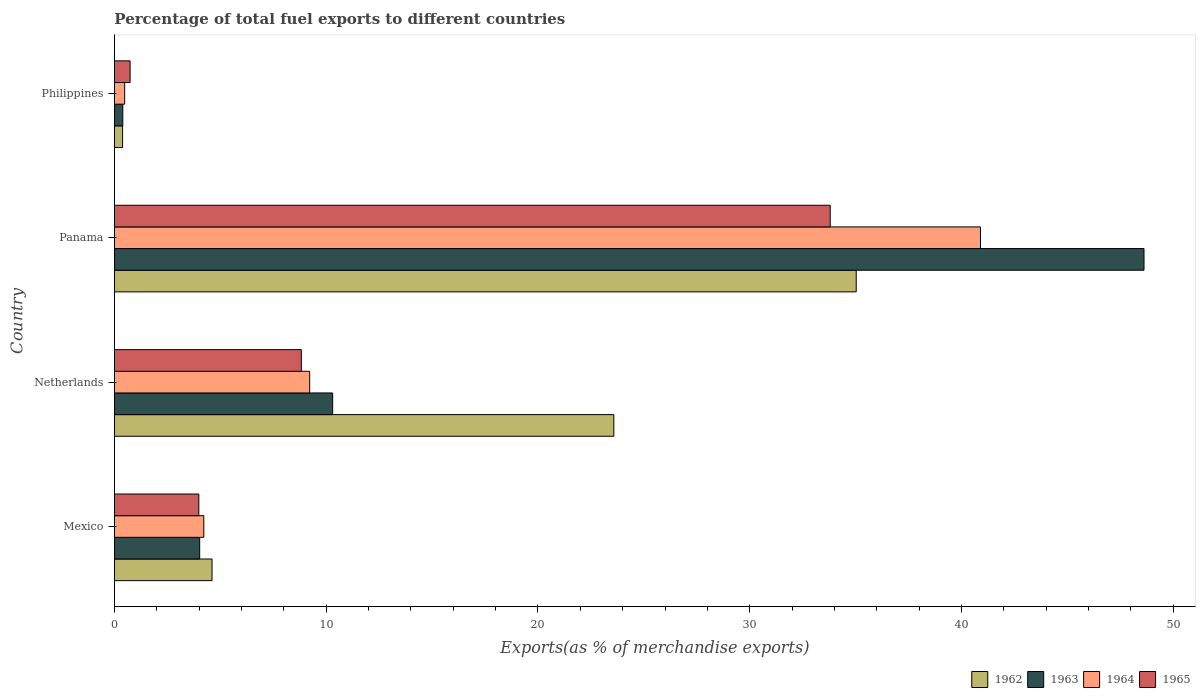How many different coloured bars are there?
Offer a terse response. 4. Are the number of bars on each tick of the Y-axis equal?
Keep it short and to the point. Yes. How many bars are there on the 1st tick from the top?
Your answer should be very brief. 4. How many bars are there on the 2nd tick from the bottom?
Provide a short and direct response. 4. In how many cases, is the number of bars for a given country not equal to the number of legend labels?
Your answer should be compact. 0. What is the percentage of exports to different countries in 1963 in Panama?
Ensure brevity in your answer.  48.62. Across all countries, what is the maximum percentage of exports to different countries in 1964?
Make the answer very short. 40.9. Across all countries, what is the minimum percentage of exports to different countries in 1962?
Provide a short and direct response. 0.38. In which country was the percentage of exports to different countries in 1963 maximum?
Provide a short and direct response. Panama. What is the total percentage of exports to different countries in 1965 in the graph?
Make the answer very short. 47.35. What is the difference between the percentage of exports to different countries in 1962 in Panama and that in Philippines?
Your answer should be very brief. 34.64. What is the difference between the percentage of exports to different countries in 1962 in Mexico and the percentage of exports to different countries in 1965 in Panama?
Give a very brief answer. -29.19. What is the average percentage of exports to different countries in 1963 per country?
Provide a succinct answer. 15.84. What is the difference between the percentage of exports to different countries in 1962 and percentage of exports to different countries in 1964 in Netherlands?
Offer a very short reply. 14.36. In how many countries, is the percentage of exports to different countries in 1962 greater than 14 %?
Give a very brief answer. 2. What is the ratio of the percentage of exports to different countries in 1963 in Mexico to that in Philippines?
Provide a short and direct response. 10.17. What is the difference between the highest and the second highest percentage of exports to different countries in 1963?
Your answer should be compact. 38.32. What is the difference between the highest and the lowest percentage of exports to different countries in 1965?
Offer a very short reply. 33.06. Is it the case that in every country, the sum of the percentage of exports to different countries in 1965 and percentage of exports to different countries in 1963 is greater than the sum of percentage of exports to different countries in 1962 and percentage of exports to different countries in 1964?
Your answer should be very brief. No. What does the 2nd bar from the top in Panama represents?
Ensure brevity in your answer.  1964. What does the 4th bar from the bottom in Netherlands represents?
Provide a short and direct response. 1965. Is it the case that in every country, the sum of the percentage of exports to different countries in 1964 and percentage of exports to different countries in 1962 is greater than the percentage of exports to different countries in 1963?
Keep it short and to the point. Yes. How many bars are there?
Ensure brevity in your answer.  16. How many countries are there in the graph?
Offer a terse response. 4. Does the graph contain any zero values?
Your response must be concise. No. Does the graph contain grids?
Offer a terse response. No. Where does the legend appear in the graph?
Ensure brevity in your answer.  Bottom right. How many legend labels are there?
Ensure brevity in your answer.  4. What is the title of the graph?
Provide a succinct answer. Percentage of total fuel exports to different countries. Does "1979" appear as one of the legend labels in the graph?
Your response must be concise. No. What is the label or title of the X-axis?
Your response must be concise. Exports(as % of merchandise exports). What is the label or title of the Y-axis?
Make the answer very short. Country. What is the Exports(as % of merchandise exports) of 1962 in Mexico?
Provide a short and direct response. 4.61. What is the Exports(as % of merchandise exports) in 1963 in Mexico?
Provide a succinct answer. 4.03. What is the Exports(as % of merchandise exports) of 1964 in Mexico?
Provide a succinct answer. 4.22. What is the Exports(as % of merchandise exports) in 1965 in Mexico?
Your answer should be very brief. 3.99. What is the Exports(as % of merchandise exports) of 1962 in Netherlands?
Offer a very short reply. 23.58. What is the Exports(as % of merchandise exports) of 1963 in Netherlands?
Offer a terse response. 10.31. What is the Exports(as % of merchandise exports) in 1964 in Netherlands?
Your response must be concise. 9.22. What is the Exports(as % of merchandise exports) of 1965 in Netherlands?
Give a very brief answer. 8.83. What is the Exports(as % of merchandise exports) in 1962 in Panama?
Your response must be concise. 35.03. What is the Exports(as % of merchandise exports) in 1963 in Panama?
Ensure brevity in your answer.  48.62. What is the Exports(as % of merchandise exports) in 1964 in Panama?
Keep it short and to the point. 40.9. What is the Exports(as % of merchandise exports) in 1965 in Panama?
Keep it short and to the point. 33.8. What is the Exports(as % of merchandise exports) in 1962 in Philippines?
Make the answer very short. 0.38. What is the Exports(as % of merchandise exports) in 1963 in Philippines?
Your answer should be very brief. 0.4. What is the Exports(as % of merchandise exports) in 1964 in Philippines?
Make the answer very short. 0.48. What is the Exports(as % of merchandise exports) in 1965 in Philippines?
Give a very brief answer. 0.74. Across all countries, what is the maximum Exports(as % of merchandise exports) of 1962?
Your response must be concise. 35.03. Across all countries, what is the maximum Exports(as % of merchandise exports) of 1963?
Your answer should be very brief. 48.62. Across all countries, what is the maximum Exports(as % of merchandise exports) of 1964?
Your response must be concise. 40.9. Across all countries, what is the maximum Exports(as % of merchandise exports) in 1965?
Keep it short and to the point. 33.8. Across all countries, what is the minimum Exports(as % of merchandise exports) in 1962?
Provide a succinct answer. 0.38. Across all countries, what is the minimum Exports(as % of merchandise exports) in 1963?
Your answer should be very brief. 0.4. Across all countries, what is the minimum Exports(as % of merchandise exports) in 1964?
Your answer should be very brief. 0.48. Across all countries, what is the minimum Exports(as % of merchandise exports) in 1965?
Ensure brevity in your answer.  0.74. What is the total Exports(as % of merchandise exports) of 1962 in the graph?
Your response must be concise. 63.61. What is the total Exports(as % of merchandise exports) in 1963 in the graph?
Your answer should be compact. 63.35. What is the total Exports(as % of merchandise exports) in 1964 in the graph?
Your answer should be very brief. 54.82. What is the total Exports(as % of merchandise exports) of 1965 in the graph?
Make the answer very short. 47.35. What is the difference between the Exports(as % of merchandise exports) in 1962 in Mexico and that in Netherlands?
Ensure brevity in your answer.  -18.97. What is the difference between the Exports(as % of merchandise exports) of 1963 in Mexico and that in Netherlands?
Provide a short and direct response. -6.28. What is the difference between the Exports(as % of merchandise exports) of 1964 in Mexico and that in Netherlands?
Offer a terse response. -5. What is the difference between the Exports(as % of merchandise exports) of 1965 in Mexico and that in Netherlands?
Make the answer very short. -4.84. What is the difference between the Exports(as % of merchandise exports) of 1962 in Mexico and that in Panama?
Offer a very short reply. -30.42. What is the difference between the Exports(as % of merchandise exports) of 1963 in Mexico and that in Panama?
Give a very brief answer. -44.59. What is the difference between the Exports(as % of merchandise exports) in 1964 in Mexico and that in Panama?
Your response must be concise. -36.68. What is the difference between the Exports(as % of merchandise exports) in 1965 in Mexico and that in Panama?
Make the answer very short. -29.82. What is the difference between the Exports(as % of merchandise exports) in 1962 in Mexico and that in Philippines?
Your answer should be compact. 4.22. What is the difference between the Exports(as % of merchandise exports) of 1963 in Mexico and that in Philippines?
Provide a short and direct response. 3.63. What is the difference between the Exports(as % of merchandise exports) in 1964 in Mexico and that in Philippines?
Give a very brief answer. 3.74. What is the difference between the Exports(as % of merchandise exports) in 1965 in Mexico and that in Philippines?
Keep it short and to the point. 3.25. What is the difference between the Exports(as % of merchandise exports) in 1962 in Netherlands and that in Panama?
Make the answer very short. -11.45. What is the difference between the Exports(as % of merchandise exports) in 1963 in Netherlands and that in Panama?
Make the answer very short. -38.32. What is the difference between the Exports(as % of merchandise exports) of 1964 in Netherlands and that in Panama?
Keep it short and to the point. -31.68. What is the difference between the Exports(as % of merchandise exports) in 1965 in Netherlands and that in Panama?
Make the answer very short. -24.98. What is the difference between the Exports(as % of merchandise exports) in 1962 in Netherlands and that in Philippines?
Offer a very short reply. 23.2. What is the difference between the Exports(as % of merchandise exports) in 1963 in Netherlands and that in Philippines?
Your response must be concise. 9.91. What is the difference between the Exports(as % of merchandise exports) in 1964 in Netherlands and that in Philippines?
Make the answer very short. 8.74. What is the difference between the Exports(as % of merchandise exports) in 1965 in Netherlands and that in Philippines?
Give a very brief answer. 8.09. What is the difference between the Exports(as % of merchandise exports) of 1962 in Panama and that in Philippines?
Offer a very short reply. 34.65. What is the difference between the Exports(as % of merchandise exports) in 1963 in Panama and that in Philippines?
Provide a short and direct response. 48.22. What is the difference between the Exports(as % of merchandise exports) of 1964 in Panama and that in Philippines?
Make the answer very short. 40.41. What is the difference between the Exports(as % of merchandise exports) in 1965 in Panama and that in Philippines?
Keep it short and to the point. 33.06. What is the difference between the Exports(as % of merchandise exports) in 1962 in Mexico and the Exports(as % of merchandise exports) in 1963 in Netherlands?
Provide a short and direct response. -5.7. What is the difference between the Exports(as % of merchandise exports) of 1962 in Mexico and the Exports(as % of merchandise exports) of 1964 in Netherlands?
Keep it short and to the point. -4.61. What is the difference between the Exports(as % of merchandise exports) of 1962 in Mexico and the Exports(as % of merchandise exports) of 1965 in Netherlands?
Your answer should be very brief. -4.22. What is the difference between the Exports(as % of merchandise exports) of 1963 in Mexico and the Exports(as % of merchandise exports) of 1964 in Netherlands?
Your response must be concise. -5.19. What is the difference between the Exports(as % of merchandise exports) of 1963 in Mexico and the Exports(as % of merchandise exports) of 1965 in Netherlands?
Keep it short and to the point. -4.8. What is the difference between the Exports(as % of merchandise exports) in 1964 in Mexico and the Exports(as % of merchandise exports) in 1965 in Netherlands?
Offer a very short reply. -4.61. What is the difference between the Exports(as % of merchandise exports) of 1962 in Mexico and the Exports(as % of merchandise exports) of 1963 in Panama?
Provide a succinct answer. -44.01. What is the difference between the Exports(as % of merchandise exports) in 1962 in Mexico and the Exports(as % of merchandise exports) in 1964 in Panama?
Keep it short and to the point. -36.29. What is the difference between the Exports(as % of merchandise exports) in 1962 in Mexico and the Exports(as % of merchandise exports) in 1965 in Panama?
Your answer should be very brief. -29.19. What is the difference between the Exports(as % of merchandise exports) of 1963 in Mexico and the Exports(as % of merchandise exports) of 1964 in Panama?
Offer a very short reply. -36.87. What is the difference between the Exports(as % of merchandise exports) of 1963 in Mexico and the Exports(as % of merchandise exports) of 1965 in Panama?
Ensure brevity in your answer.  -29.78. What is the difference between the Exports(as % of merchandise exports) in 1964 in Mexico and the Exports(as % of merchandise exports) in 1965 in Panama?
Make the answer very short. -29.58. What is the difference between the Exports(as % of merchandise exports) in 1962 in Mexico and the Exports(as % of merchandise exports) in 1963 in Philippines?
Provide a succinct answer. 4.21. What is the difference between the Exports(as % of merchandise exports) of 1962 in Mexico and the Exports(as % of merchandise exports) of 1964 in Philippines?
Your answer should be very brief. 4.13. What is the difference between the Exports(as % of merchandise exports) in 1962 in Mexico and the Exports(as % of merchandise exports) in 1965 in Philippines?
Make the answer very short. 3.87. What is the difference between the Exports(as % of merchandise exports) in 1963 in Mexico and the Exports(as % of merchandise exports) in 1964 in Philippines?
Give a very brief answer. 3.54. What is the difference between the Exports(as % of merchandise exports) in 1963 in Mexico and the Exports(as % of merchandise exports) in 1965 in Philippines?
Your answer should be very brief. 3.29. What is the difference between the Exports(as % of merchandise exports) of 1964 in Mexico and the Exports(as % of merchandise exports) of 1965 in Philippines?
Make the answer very short. 3.48. What is the difference between the Exports(as % of merchandise exports) of 1962 in Netherlands and the Exports(as % of merchandise exports) of 1963 in Panama?
Your answer should be very brief. -25.04. What is the difference between the Exports(as % of merchandise exports) in 1962 in Netherlands and the Exports(as % of merchandise exports) in 1964 in Panama?
Offer a very short reply. -17.31. What is the difference between the Exports(as % of merchandise exports) in 1962 in Netherlands and the Exports(as % of merchandise exports) in 1965 in Panama?
Ensure brevity in your answer.  -10.22. What is the difference between the Exports(as % of merchandise exports) in 1963 in Netherlands and the Exports(as % of merchandise exports) in 1964 in Panama?
Your response must be concise. -30.59. What is the difference between the Exports(as % of merchandise exports) of 1963 in Netherlands and the Exports(as % of merchandise exports) of 1965 in Panama?
Give a very brief answer. -23.5. What is the difference between the Exports(as % of merchandise exports) of 1964 in Netherlands and the Exports(as % of merchandise exports) of 1965 in Panama?
Make the answer very short. -24.58. What is the difference between the Exports(as % of merchandise exports) of 1962 in Netherlands and the Exports(as % of merchandise exports) of 1963 in Philippines?
Provide a succinct answer. 23.19. What is the difference between the Exports(as % of merchandise exports) in 1962 in Netherlands and the Exports(as % of merchandise exports) in 1964 in Philippines?
Offer a terse response. 23.1. What is the difference between the Exports(as % of merchandise exports) in 1962 in Netherlands and the Exports(as % of merchandise exports) in 1965 in Philippines?
Your answer should be compact. 22.84. What is the difference between the Exports(as % of merchandise exports) of 1963 in Netherlands and the Exports(as % of merchandise exports) of 1964 in Philippines?
Keep it short and to the point. 9.82. What is the difference between the Exports(as % of merchandise exports) in 1963 in Netherlands and the Exports(as % of merchandise exports) in 1965 in Philippines?
Ensure brevity in your answer.  9.57. What is the difference between the Exports(as % of merchandise exports) of 1964 in Netherlands and the Exports(as % of merchandise exports) of 1965 in Philippines?
Your answer should be compact. 8.48. What is the difference between the Exports(as % of merchandise exports) in 1962 in Panama and the Exports(as % of merchandise exports) in 1963 in Philippines?
Provide a succinct answer. 34.63. What is the difference between the Exports(as % of merchandise exports) of 1962 in Panama and the Exports(as % of merchandise exports) of 1964 in Philippines?
Give a very brief answer. 34.55. What is the difference between the Exports(as % of merchandise exports) of 1962 in Panama and the Exports(as % of merchandise exports) of 1965 in Philippines?
Give a very brief answer. 34.29. What is the difference between the Exports(as % of merchandise exports) of 1963 in Panama and the Exports(as % of merchandise exports) of 1964 in Philippines?
Your answer should be compact. 48.14. What is the difference between the Exports(as % of merchandise exports) of 1963 in Panama and the Exports(as % of merchandise exports) of 1965 in Philippines?
Keep it short and to the point. 47.88. What is the difference between the Exports(as % of merchandise exports) of 1964 in Panama and the Exports(as % of merchandise exports) of 1965 in Philippines?
Your response must be concise. 40.16. What is the average Exports(as % of merchandise exports) of 1962 per country?
Ensure brevity in your answer.  15.9. What is the average Exports(as % of merchandise exports) in 1963 per country?
Make the answer very short. 15.84. What is the average Exports(as % of merchandise exports) in 1964 per country?
Your response must be concise. 13.71. What is the average Exports(as % of merchandise exports) of 1965 per country?
Make the answer very short. 11.84. What is the difference between the Exports(as % of merchandise exports) of 1962 and Exports(as % of merchandise exports) of 1963 in Mexico?
Ensure brevity in your answer.  0.58. What is the difference between the Exports(as % of merchandise exports) of 1962 and Exports(as % of merchandise exports) of 1964 in Mexico?
Your response must be concise. 0.39. What is the difference between the Exports(as % of merchandise exports) of 1962 and Exports(as % of merchandise exports) of 1965 in Mexico?
Make the answer very short. 0.62. What is the difference between the Exports(as % of merchandise exports) of 1963 and Exports(as % of merchandise exports) of 1964 in Mexico?
Your answer should be compact. -0.19. What is the difference between the Exports(as % of merchandise exports) of 1963 and Exports(as % of merchandise exports) of 1965 in Mexico?
Offer a terse response. 0.04. What is the difference between the Exports(as % of merchandise exports) of 1964 and Exports(as % of merchandise exports) of 1965 in Mexico?
Keep it short and to the point. 0.23. What is the difference between the Exports(as % of merchandise exports) in 1962 and Exports(as % of merchandise exports) in 1963 in Netherlands?
Make the answer very short. 13.28. What is the difference between the Exports(as % of merchandise exports) of 1962 and Exports(as % of merchandise exports) of 1964 in Netherlands?
Make the answer very short. 14.36. What is the difference between the Exports(as % of merchandise exports) in 1962 and Exports(as % of merchandise exports) in 1965 in Netherlands?
Provide a succinct answer. 14.76. What is the difference between the Exports(as % of merchandise exports) of 1963 and Exports(as % of merchandise exports) of 1964 in Netherlands?
Give a very brief answer. 1.09. What is the difference between the Exports(as % of merchandise exports) in 1963 and Exports(as % of merchandise exports) in 1965 in Netherlands?
Your response must be concise. 1.48. What is the difference between the Exports(as % of merchandise exports) in 1964 and Exports(as % of merchandise exports) in 1965 in Netherlands?
Give a very brief answer. 0.39. What is the difference between the Exports(as % of merchandise exports) in 1962 and Exports(as % of merchandise exports) in 1963 in Panama?
Give a very brief answer. -13.59. What is the difference between the Exports(as % of merchandise exports) of 1962 and Exports(as % of merchandise exports) of 1964 in Panama?
Offer a terse response. -5.87. What is the difference between the Exports(as % of merchandise exports) in 1962 and Exports(as % of merchandise exports) in 1965 in Panama?
Your answer should be compact. 1.23. What is the difference between the Exports(as % of merchandise exports) in 1963 and Exports(as % of merchandise exports) in 1964 in Panama?
Your response must be concise. 7.72. What is the difference between the Exports(as % of merchandise exports) of 1963 and Exports(as % of merchandise exports) of 1965 in Panama?
Offer a very short reply. 14.82. What is the difference between the Exports(as % of merchandise exports) of 1964 and Exports(as % of merchandise exports) of 1965 in Panama?
Offer a terse response. 7.1. What is the difference between the Exports(as % of merchandise exports) in 1962 and Exports(as % of merchandise exports) in 1963 in Philippines?
Provide a short and direct response. -0.01. What is the difference between the Exports(as % of merchandise exports) of 1962 and Exports(as % of merchandise exports) of 1964 in Philippines?
Your answer should be compact. -0.1. What is the difference between the Exports(as % of merchandise exports) of 1962 and Exports(as % of merchandise exports) of 1965 in Philippines?
Provide a short and direct response. -0.35. What is the difference between the Exports(as % of merchandise exports) in 1963 and Exports(as % of merchandise exports) in 1964 in Philippines?
Give a very brief answer. -0.09. What is the difference between the Exports(as % of merchandise exports) in 1963 and Exports(as % of merchandise exports) in 1965 in Philippines?
Provide a short and direct response. -0.34. What is the difference between the Exports(as % of merchandise exports) in 1964 and Exports(as % of merchandise exports) in 1965 in Philippines?
Provide a succinct answer. -0.26. What is the ratio of the Exports(as % of merchandise exports) of 1962 in Mexico to that in Netherlands?
Ensure brevity in your answer.  0.2. What is the ratio of the Exports(as % of merchandise exports) in 1963 in Mexico to that in Netherlands?
Give a very brief answer. 0.39. What is the ratio of the Exports(as % of merchandise exports) of 1964 in Mexico to that in Netherlands?
Keep it short and to the point. 0.46. What is the ratio of the Exports(as % of merchandise exports) of 1965 in Mexico to that in Netherlands?
Provide a succinct answer. 0.45. What is the ratio of the Exports(as % of merchandise exports) in 1962 in Mexico to that in Panama?
Keep it short and to the point. 0.13. What is the ratio of the Exports(as % of merchandise exports) of 1963 in Mexico to that in Panama?
Provide a succinct answer. 0.08. What is the ratio of the Exports(as % of merchandise exports) of 1964 in Mexico to that in Panama?
Offer a very short reply. 0.1. What is the ratio of the Exports(as % of merchandise exports) in 1965 in Mexico to that in Panama?
Provide a succinct answer. 0.12. What is the ratio of the Exports(as % of merchandise exports) in 1962 in Mexico to that in Philippines?
Your response must be concise. 11.97. What is the ratio of the Exports(as % of merchandise exports) in 1963 in Mexico to that in Philippines?
Your answer should be compact. 10.17. What is the ratio of the Exports(as % of merchandise exports) of 1964 in Mexico to that in Philippines?
Your answer should be very brief. 8.73. What is the ratio of the Exports(as % of merchandise exports) in 1965 in Mexico to that in Philippines?
Your answer should be compact. 5.39. What is the ratio of the Exports(as % of merchandise exports) of 1962 in Netherlands to that in Panama?
Ensure brevity in your answer.  0.67. What is the ratio of the Exports(as % of merchandise exports) of 1963 in Netherlands to that in Panama?
Your response must be concise. 0.21. What is the ratio of the Exports(as % of merchandise exports) in 1964 in Netherlands to that in Panama?
Your response must be concise. 0.23. What is the ratio of the Exports(as % of merchandise exports) in 1965 in Netherlands to that in Panama?
Provide a succinct answer. 0.26. What is the ratio of the Exports(as % of merchandise exports) of 1962 in Netherlands to that in Philippines?
Your response must be concise. 61.27. What is the ratio of the Exports(as % of merchandise exports) of 1963 in Netherlands to that in Philippines?
Ensure brevity in your answer.  26.03. What is the ratio of the Exports(as % of merchandise exports) of 1964 in Netherlands to that in Philippines?
Your answer should be compact. 19.07. What is the ratio of the Exports(as % of merchandise exports) of 1965 in Netherlands to that in Philippines?
Keep it short and to the point. 11.93. What is the ratio of the Exports(as % of merchandise exports) of 1962 in Panama to that in Philippines?
Offer a terse response. 91.01. What is the ratio of the Exports(as % of merchandise exports) of 1963 in Panama to that in Philippines?
Keep it short and to the point. 122.82. What is the ratio of the Exports(as % of merchandise exports) in 1964 in Panama to that in Philippines?
Give a very brief answer. 84.6. What is the ratio of the Exports(as % of merchandise exports) of 1965 in Panama to that in Philippines?
Make the answer very short. 45.69. What is the difference between the highest and the second highest Exports(as % of merchandise exports) in 1962?
Offer a very short reply. 11.45. What is the difference between the highest and the second highest Exports(as % of merchandise exports) of 1963?
Your response must be concise. 38.32. What is the difference between the highest and the second highest Exports(as % of merchandise exports) of 1964?
Provide a succinct answer. 31.68. What is the difference between the highest and the second highest Exports(as % of merchandise exports) in 1965?
Keep it short and to the point. 24.98. What is the difference between the highest and the lowest Exports(as % of merchandise exports) in 1962?
Provide a short and direct response. 34.65. What is the difference between the highest and the lowest Exports(as % of merchandise exports) of 1963?
Make the answer very short. 48.22. What is the difference between the highest and the lowest Exports(as % of merchandise exports) in 1964?
Make the answer very short. 40.41. What is the difference between the highest and the lowest Exports(as % of merchandise exports) of 1965?
Provide a short and direct response. 33.06. 